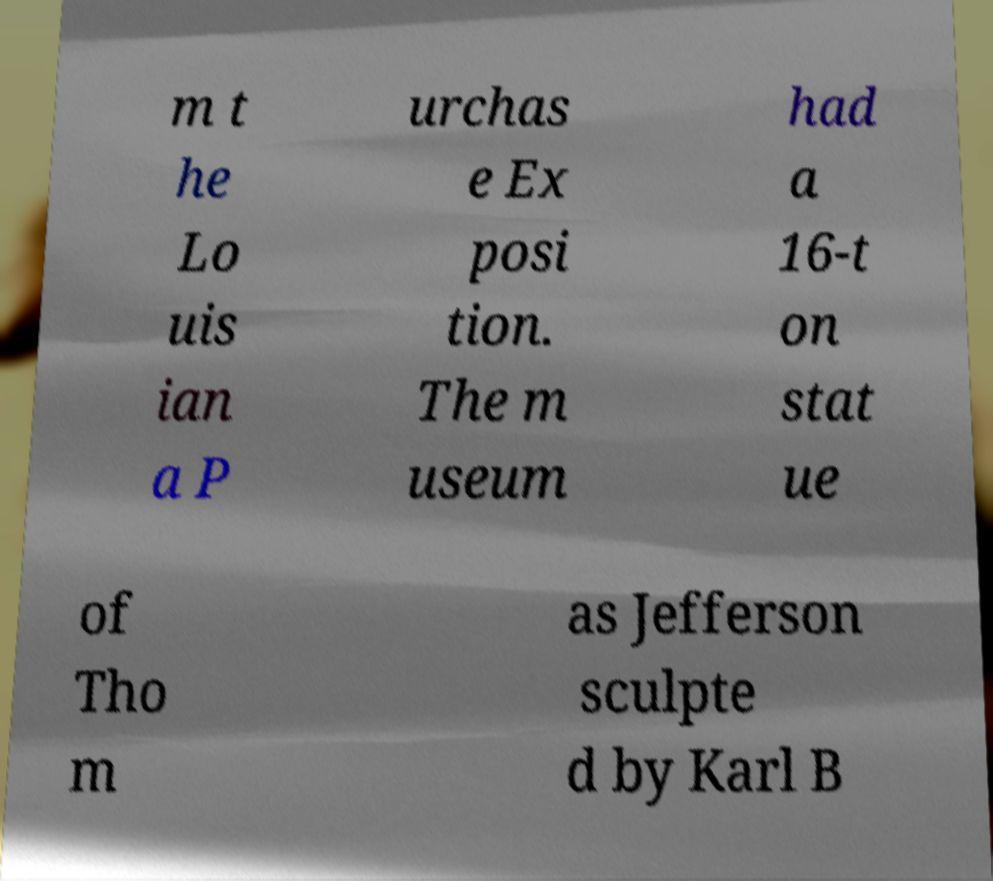Could you assist in decoding the text presented in this image and type it out clearly? m t he Lo uis ian a P urchas e Ex posi tion. The m useum had a 16-t on stat ue of Tho m as Jefferson sculpte d by Karl B 